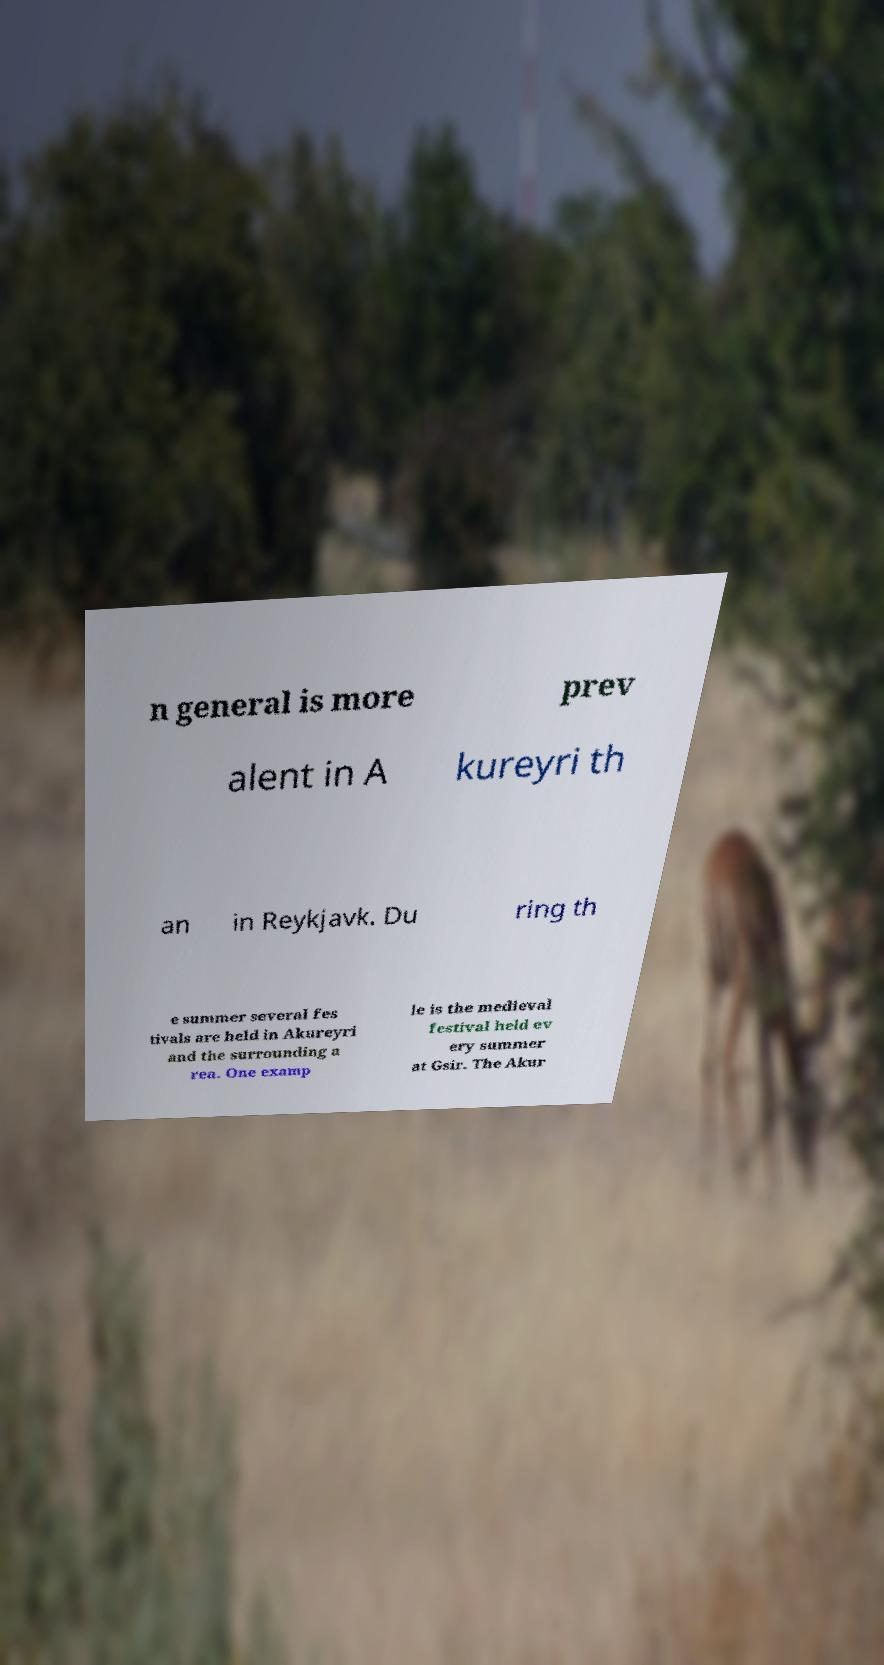Please identify and transcribe the text found in this image. n general is more prev alent in A kureyri th an in Reykjavk. Du ring th e summer several fes tivals are held in Akureyri and the surrounding a rea. One examp le is the medieval festival held ev ery summer at Gsir. The Akur 